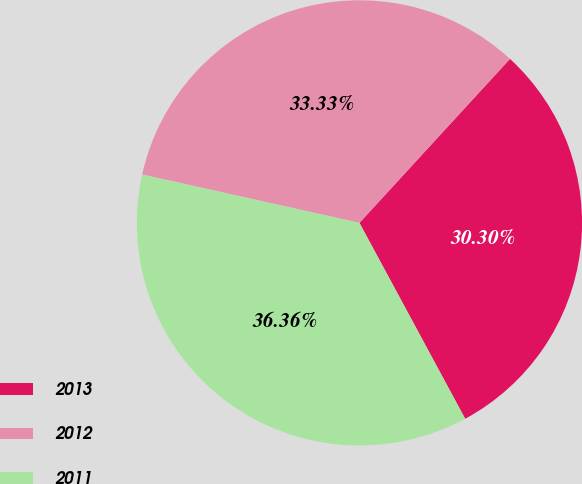<chart> <loc_0><loc_0><loc_500><loc_500><pie_chart><fcel>2013<fcel>2012<fcel>2011<nl><fcel>30.3%<fcel>33.33%<fcel>36.36%<nl></chart> 